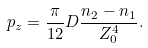<formula> <loc_0><loc_0><loc_500><loc_500>p _ { z } = \frac { \pi } { 1 2 } D \frac { n _ { 2 } - n _ { 1 } } { Z _ { 0 } ^ { 4 } } .</formula> 